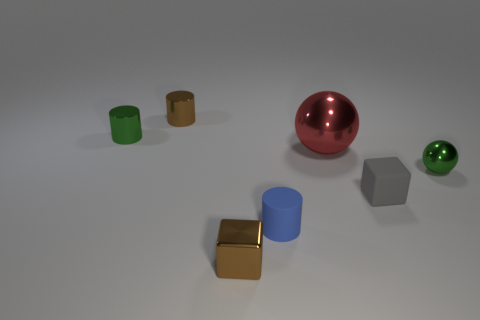What number of other shiny cylinders are the same size as the blue cylinder?
Your response must be concise. 2. Do the shiny cylinder on the right side of the tiny green cylinder and the tiny shiny cube have the same color?
Provide a short and direct response. Yes. There is a object that is behind the small gray block and in front of the large ball; what material is it made of?
Make the answer very short. Metal. Are there more small brown shiny cylinders than big matte blocks?
Give a very brief answer. Yes. There is a block that is in front of the cylinder to the right of the thing in front of the blue cylinder; what is its color?
Provide a succinct answer. Brown. Does the tiny brown object that is behind the gray object have the same material as the big thing?
Ensure brevity in your answer.  Yes. Are there any rubber objects that have the same color as the metal cube?
Give a very brief answer. No. Are any big blue rubber cylinders visible?
Your response must be concise. No. Is the size of the green metallic object that is to the right of the blue thing the same as the big red metal sphere?
Give a very brief answer. No. Are there fewer small green rubber cylinders than blue cylinders?
Keep it short and to the point. Yes. 